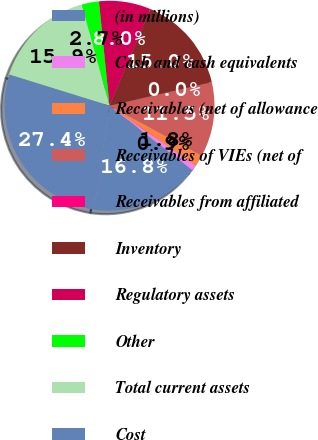<chart> <loc_0><loc_0><loc_500><loc_500><pie_chart><fcel>(in millions)<fcel>Cash and cash equivalents<fcel>Receivables (net of allowance<fcel>Receivables of VIEs (net of<fcel>Receivables from affiliated<fcel>Inventory<fcel>Regulatory assets<fcel>Other<fcel>Total current assets<fcel>Cost<nl><fcel>16.81%<fcel>0.89%<fcel>1.77%<fcel>11.5%<fcel>0.0%<fcel>15.04%<fcel>7.96%<fcel>2.66%<fcel>15.93%<fcel>27.43%<nl></chart> 